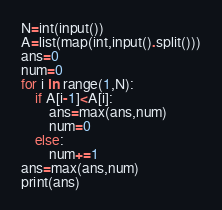<code> <loc_0><loc_0><loc_500><loc_500><_Python_>N=int(input())
A=list(map(int,input().split()))
ans=0
num=0
for i in range(1,N):
    if A[i-1]<A[i]:
        ans=max(ans,num)
        num=0
    else:
        num+=1
ans=max(ans,num)
print(ans)
</code> 